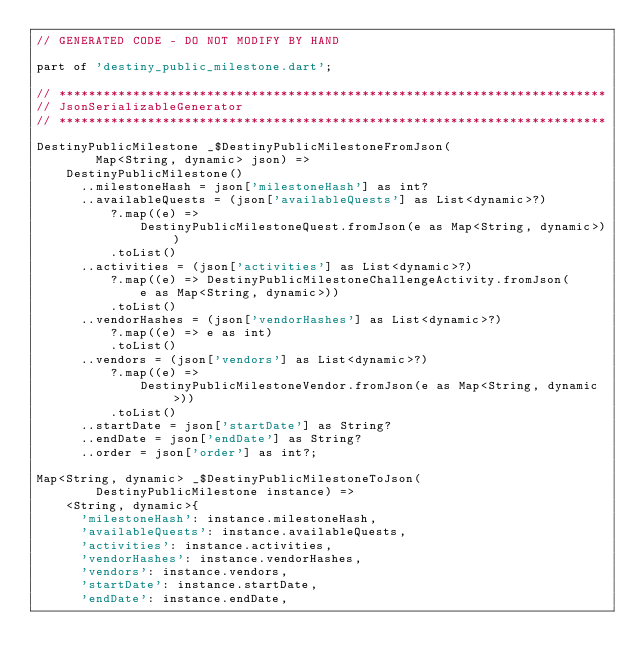Convert code to text. <code><loc_0><loc_0><loc_500><loc_500><_Dart_>// GENERATED CODE - DO NOT MODIFY BY HAND

part of 'destiny_public_milestone.dart';

// **************************************************************************
// JsonSerializableGenerator
// **************************************************************************

DestinyPublicMilestone _$DestinyPublicMilestoneFromJson(
        Map<String, dynamic> json) =>
    DestinyPublicMilestone()
      ..milestoneHash = json['milestoneHash'] as int?
      ..availableQuests = (json['availableQuests'] as List<dynamic>?)
          ?.map((e) =>
              DestinyPublicMilestoneQuest.fromJson(e as Map<String, dynamic>))
          .toList()
      ..activities = (json['activities'] as List<dynamic>?)
          ?.map((e) => DestinyPublicMilestoneChallengeActivity.fromJson(
              e as Map<String, dynamic>))
          .toList()
      ..vendorHashes = (json['vendorHashes'] as List<dynamic>?)
          ?.map((e) => e as int)
          .toList()
      ..vendors = (json['vendors'] as List<dynamic>?)
          ?.map((e) =>
              DestinyPublicMilestoneVendor.fromJson(e as Map<String, dynamic>))
          .toList()
      ..startDate = json['startDate'] as String?
      ..endDate = json['endDate'] as String?
      ..order = json['order'] as int?;

Map<String, dynamic> _$DestinyPublicMilestoneToJson(
        DestinyPublicMilestone instance) =>
    <String, dynamic>{
      'milestoneHash': instance.milestoneHash,
      'availableQuests': instance.availableQuests,
      'activities': instance.activities,
      'vendorHashes': instance.vendorHashes,
      'vendors': instance.vendors,
      'startDate': instance.startDate,
      'endDate': instance.endDate,</code> 